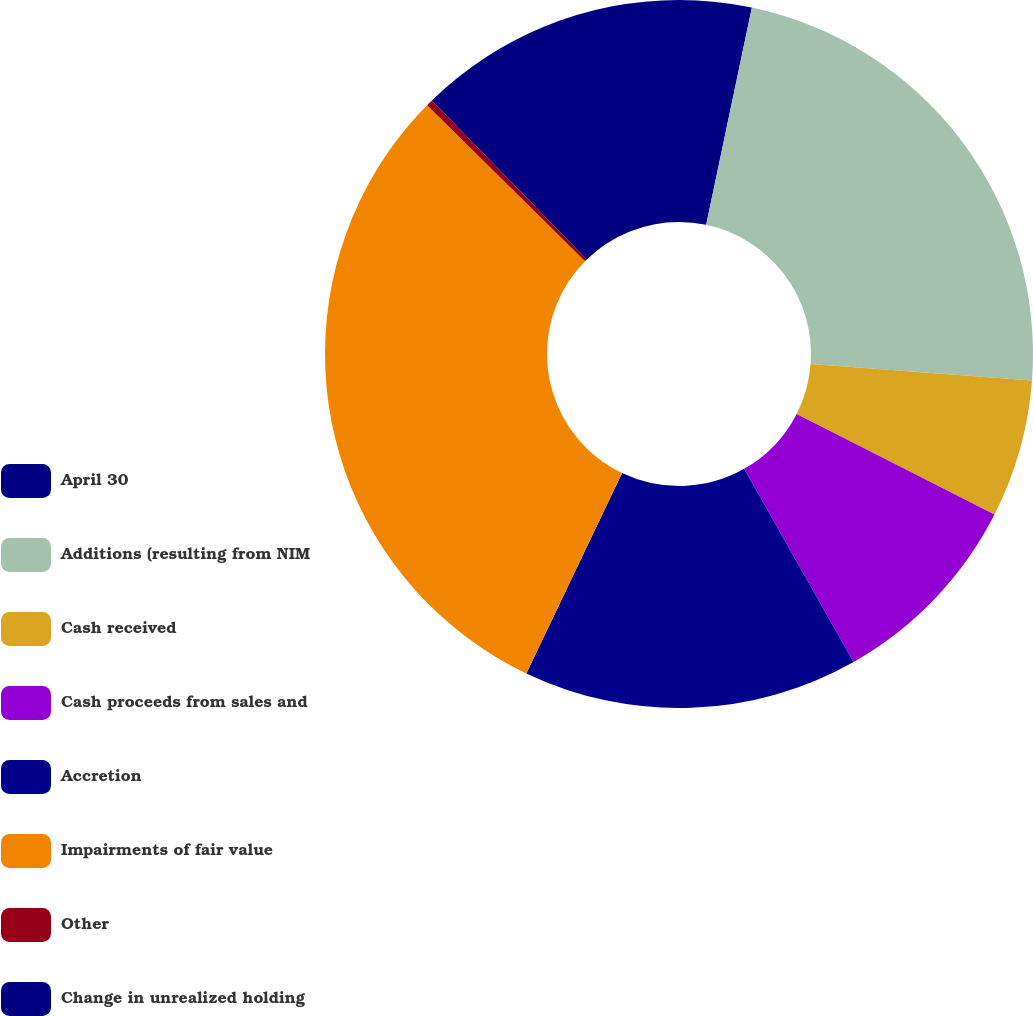Convert chart to OTSL. <chart><loc_0><loc_0><loc_500><loc_500><pie_chart><fcel>April 30<fcel>Additions (resulting from NIM<fcel>Cash received<fcel>Cash proceeds from sales and<fcel>Accretion<fcel>Impairments of fair value<fcel>Other<fcel>Change in unrealized holding<nl><fcel>3.3%<fcel>22.89%<fcel>6.3%<fcel>9.3%<fcel>15.3%<fcel>30.3%<fcel>0.3%<fcel>12.3%<nl></chart> 